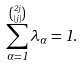<formula> <loc_0><loc_0><loc_500><loc_500>\sum _ { \alpha = 1 } ^ { { 2 j \choose { \lfloor j \rfloor } } } \lambda _ { \alpha } = 1 .</formula> 